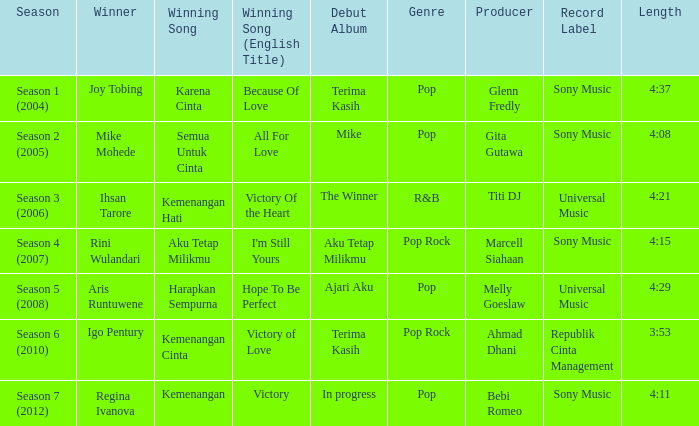Which album debuted in season 2 (2005)? Mike. 